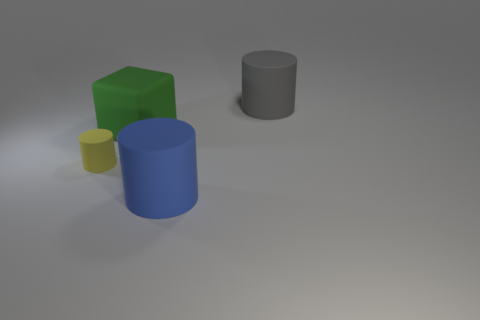How do the sizes of the objects compare to each other? The objects vary in size: the green cuboid is the largest, followed by the blue cylinder, then the gray cylinder, and the smallest is the yellow cylinder. Each size difference sets a clear hierarchy of scale. 